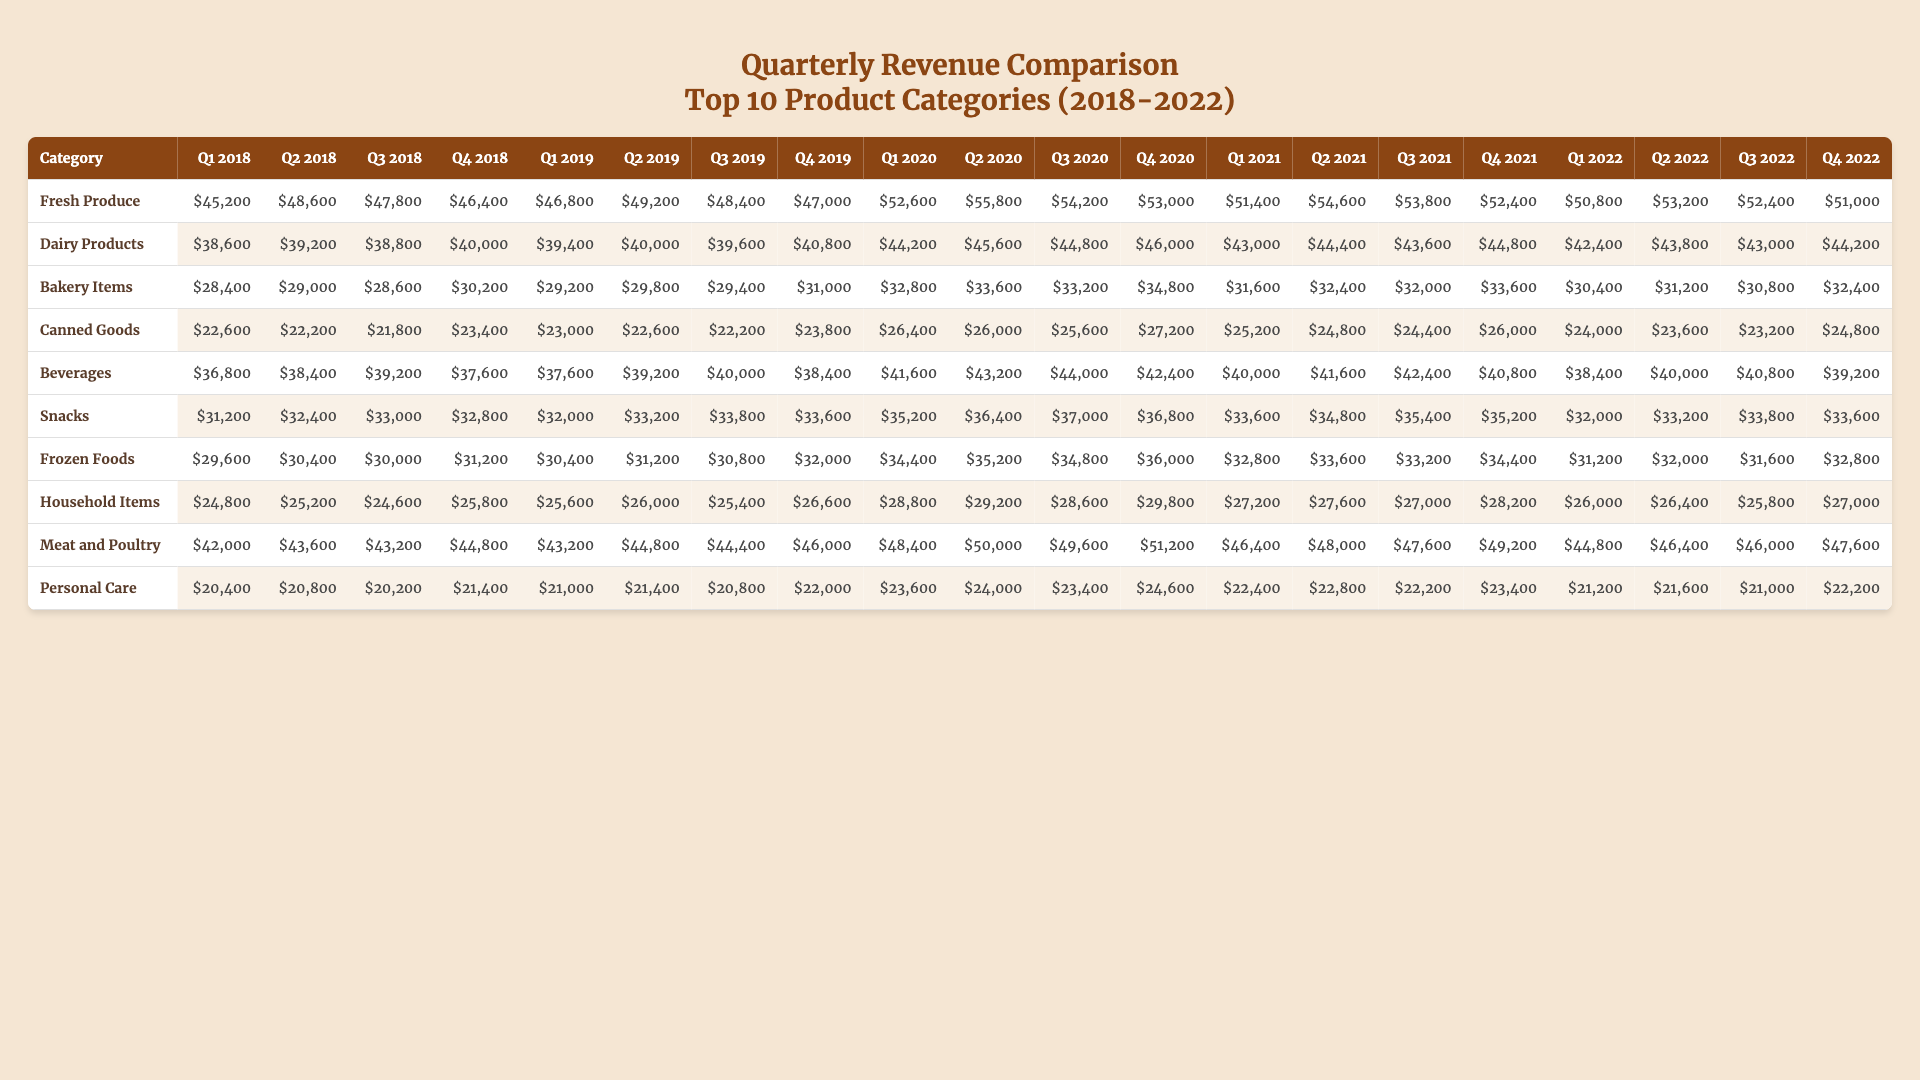What was the revenue for Fresh Produce in Q3 2020? The revenue for Fresh Produce in Q3 2020 is found directly in the table under the category of Fresh Produce and the period Q3 2020, which shows $54,200.
Answer: $54,200 Which category had the highest revenue in Q4 2021? To answer this, compare the revenue figures in the Q4 2021 column across all categories. Meat and Poultry shows the highest revenue at $49,200.
Answer: Meat and Poultry What is the total revenue for Dairy Products over the whole period? To find this, we sum the quarterly revenues for Dairy Products: 38,600 + 39,200 + 38,800 + 40,000 + 39,400 + 40,000 + 39,600 + 40,800 + 44,200 + 45,600 + 44,800 + 46,000 + 43,000 + 44,400 + 43,600 + 44,800 + 42,400 + 43,800 + 43,000 + 44,200 = $855,000.
Answer: $855,000 What is the average revenue for Snacks from Q1 2018 to Q4 2022? First, sum the revenues for Snacks over the 20 quarters: (31,200 + 32,400 + 33,000 + 32,800 + 32,000 + 33,200 + 33,800 + 33,600 + 35,200 + 36,400 + 37,000 + 36,800 + 33,600 + 34,800 + 35,400 + 35,200 + 32,000 + 33,200 + 33,800 + 33,600) = $675,200. Then divide by 20 to find the average: 675,200 / 20 = $33,760.
Answer: $33,760 Did Beverages revenue increase every quarter from Q1 2020 to Q4 2020? Looking at the Q1 to Q4 2020 data for Beverages, the revenues were $41,600, $43,200, $44,000, and $42,400. The revenue decreased from Q3 to Q4, indicating it did not increase every quarter.
Answer: No Which product category saw the largest decrease in revenue from Q4 2019 to Q1 2020? Calculate the changes: Canned Goods dropped from $23,800 in Q4 2019 to $26,400 in Q1 2020 (not a decrease). The largest drop was in Dairy Products from $40,800 in Q4 2019 to $39,400 in Q1 2020, a decrease of $1,400.
Answer: Dairy Products Identify the trend in the revenue for Frozen Foods over the five years. By inspecting the revenues quarter by quarter, we can see that Frozen Foods initially increased from $29,600 in Q1 2018 to $31,200 in Q4 2019, then generally fluctuated, with a slight increase to $32,800 in Q4 2022, indicating a relatively stable yet slowly rising trend over the period.
Answer: Slightly rising trend What was the highest revenue recorded for any category in 2022? Look across the entirety of 2022 (Q1 to Q4) to find the maximum revenue. For Meat and Poultry, the highest was $49,200 in Q4 2022, which is the highest overall.
Answer: $49,200 Is the revenue for Personal Care consistently higher than $20,000? By examining the revenue over time, we see values of $20,400, $20,800, $20,200, $21,400, $21,000, $21,400, $20,800, $22,000, $23,600, $24,000, $23,400, $24,600, $22,400, $22,800, $22,200, $23,400, $21,200, $21,600, $21,000, and $22,200, all numbers are above $20,000.
Answer: Yes What was the difference in revenue between the highest and lowest category in Q2 2021? Checking Q2 2021, the highest revenue category is Fresh Produce at $54,600 and the lowest is Canned Goods at $22,200. The difference is calculated as 54,600 - 22,200 = $32,400.
Answer: $32,400 